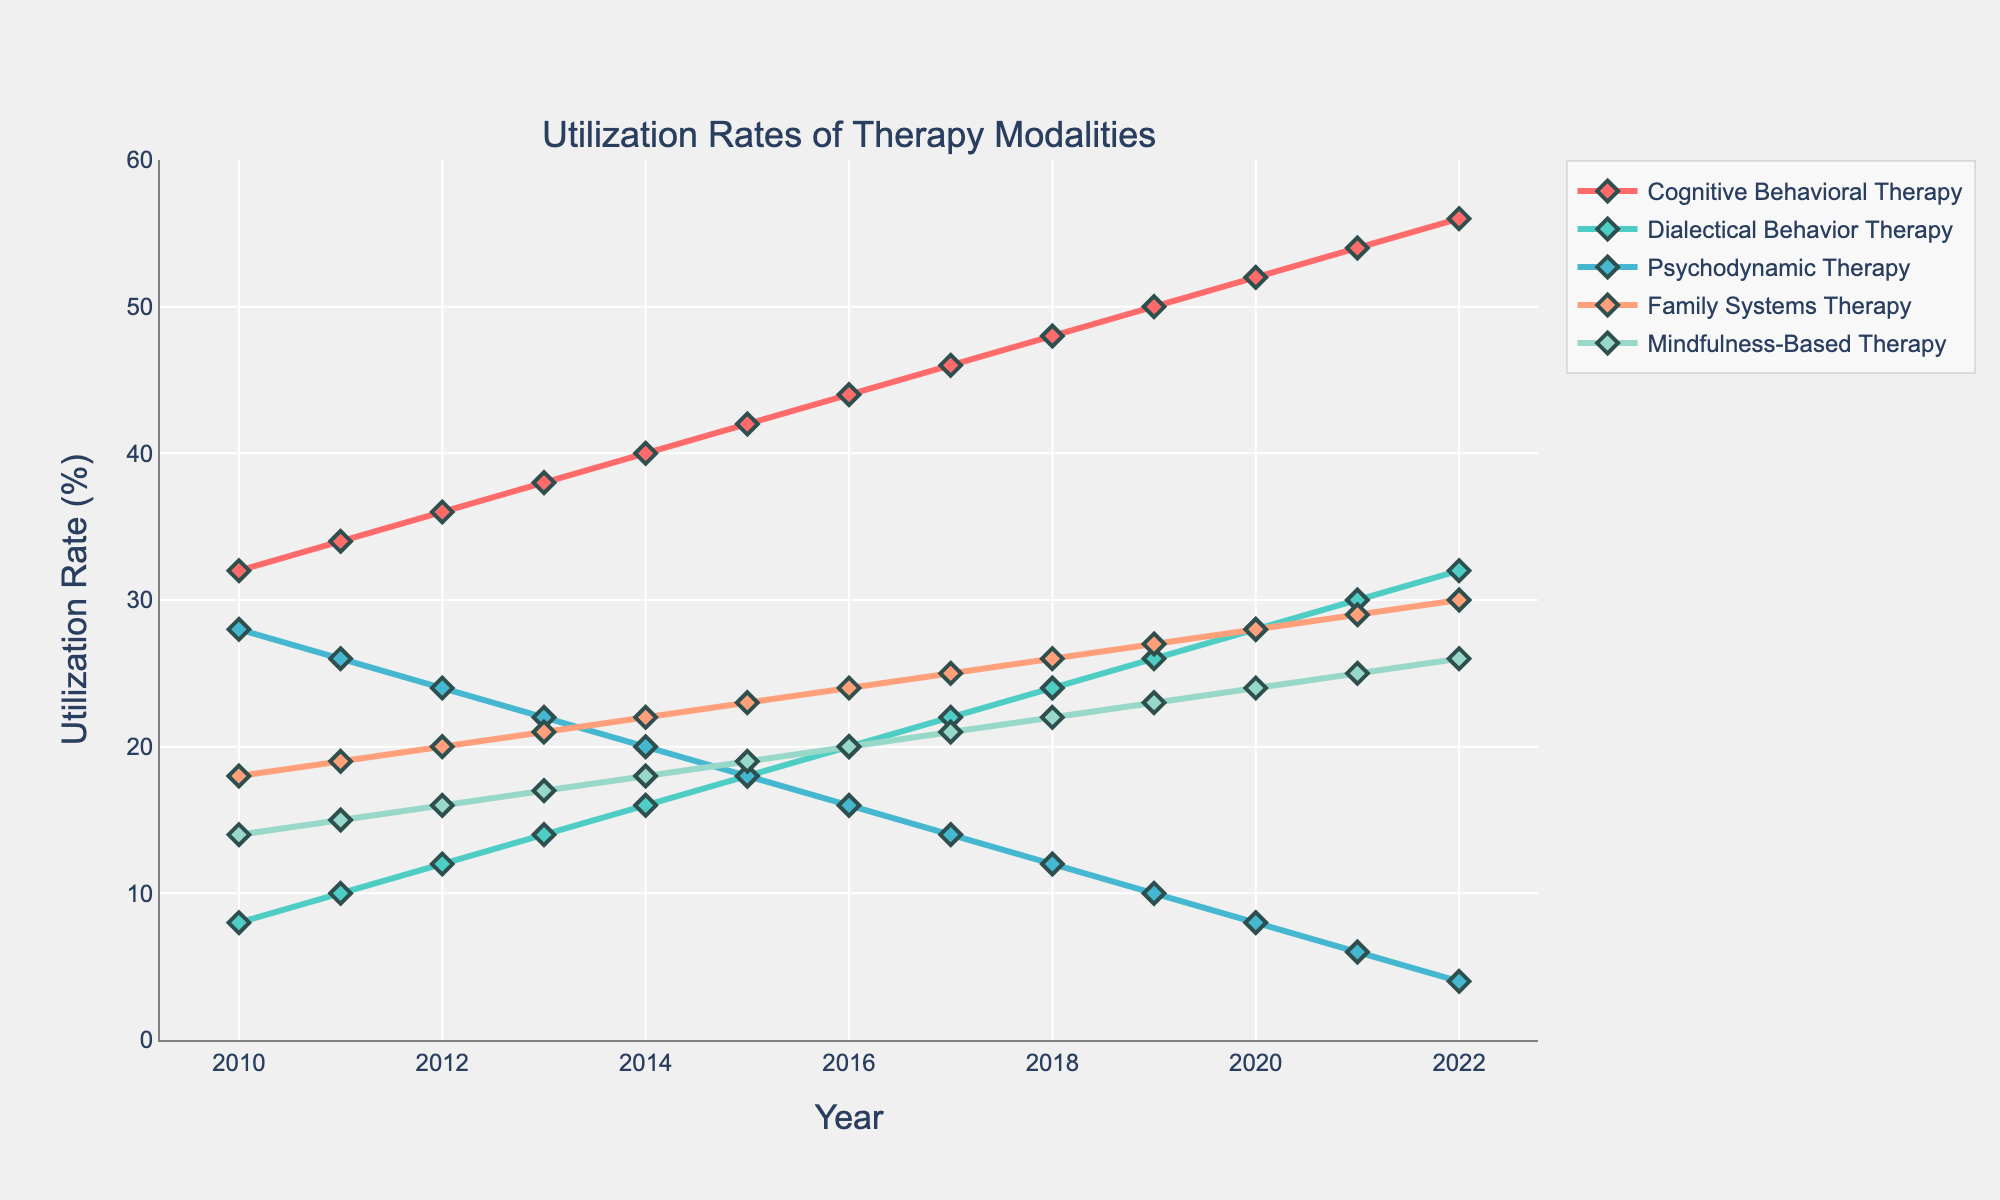what is the utilization rate of Cognitive Behavioral Therapy in 2016? Locate the line representing Cognitive Behavioral Therapy on the chart, identified by a specific color. Follow this line to the year 2016 on the x-axis and read the corresponding utilization rate on the y-axis.
Answer: 44 Which therapy modality had the highest utilization rate in 2022? Observe all the lines on the chart for the year 2022 and identify which one reaches the highest y-axis value.
Answer: Cognitive Behavioral Therapy How much did the utilization rate of Dialectical Behavior Therapy grow from 2010 to 2015? Find the utilization rate of Dialectical Behavior Therapy in 2010 and 2015 by following its line on the chart to the corresponding years and y-axis values. Then, subtract the 2010 value from the 2015 value (18 - 8).
Answer: 10 Between what years did Psychodynamic Therapy exhibit a steady decline? Track the line representing Psychodynamic Therapy across the x-axis. Identify the period during which it continuously moved downward without any increases.
Answer: 2010 to 2022 Which two therapy modalities had equal utilization rates in any specific year, and what was that rate? Scan the chart for any year where two different lines intersect, signifying equal utilization rates. Identify the specific year and the y-axis value at that intersection point.
Answer: None In 2020, what was the difference in utilization rates between Family Systems Therapy and Mindfulness-Based Therapy? Locate the utilization rates of Family Systems Therapy and Mindfulness-Based Therapy in 2020 by following their lines on the chart to the 2020 year on the x-axis and note their y-axis values. Then, subtract the smaller value from the larger one (28 - 24).
Answer: 4 What was the average utilization rate of Mindfulness-Based Therapy from 2010 to 2022? Sum the utilization rates of Mindfulness-Based Therapy from 2010 to 2022, then divide by the number of years (14+15+16+17+18+19+20+21+22+23+24+25+26)/13.
Answer: 20 Which therapy modality shows the most significant gradual increase over time? Observe the slopes of the lines, looking for the one with the most consistent and significant upward trend across the years.
Answer: Cognitive Behavioral Therapy What is the combined utilization rate of Cognitive Behavioral Therapy and Family Systems Therapy in 2014? Find the utilization rates of Cognitive Behavioral Therapy and Family Systems Therapy for 2014 on their respective lines, then sum the two values (40 + 22).
Answer: 62 How many therapy modalities had utilization rates of 20% or more in 2013? For the year 2013, identify which lines are at or above the 20% mark on the y-axis and count these lines.
Answer: 2 